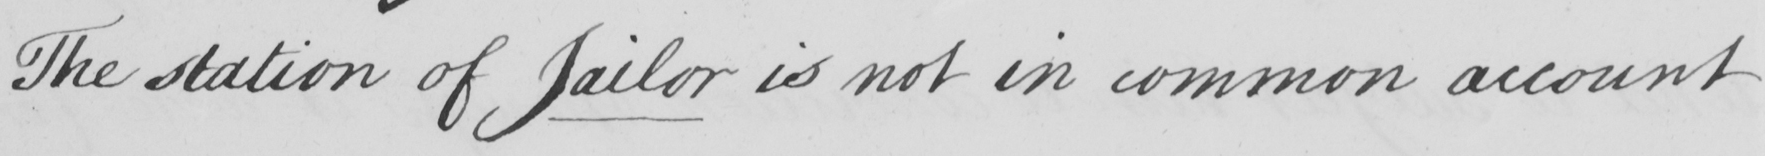What does this handwritten line say? The station of Jailor is not in common account 